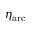Convert formula to latex. <formula><loc_0><loc_0><loc_500><loc_500>\eta _ { a r c }</formula> 